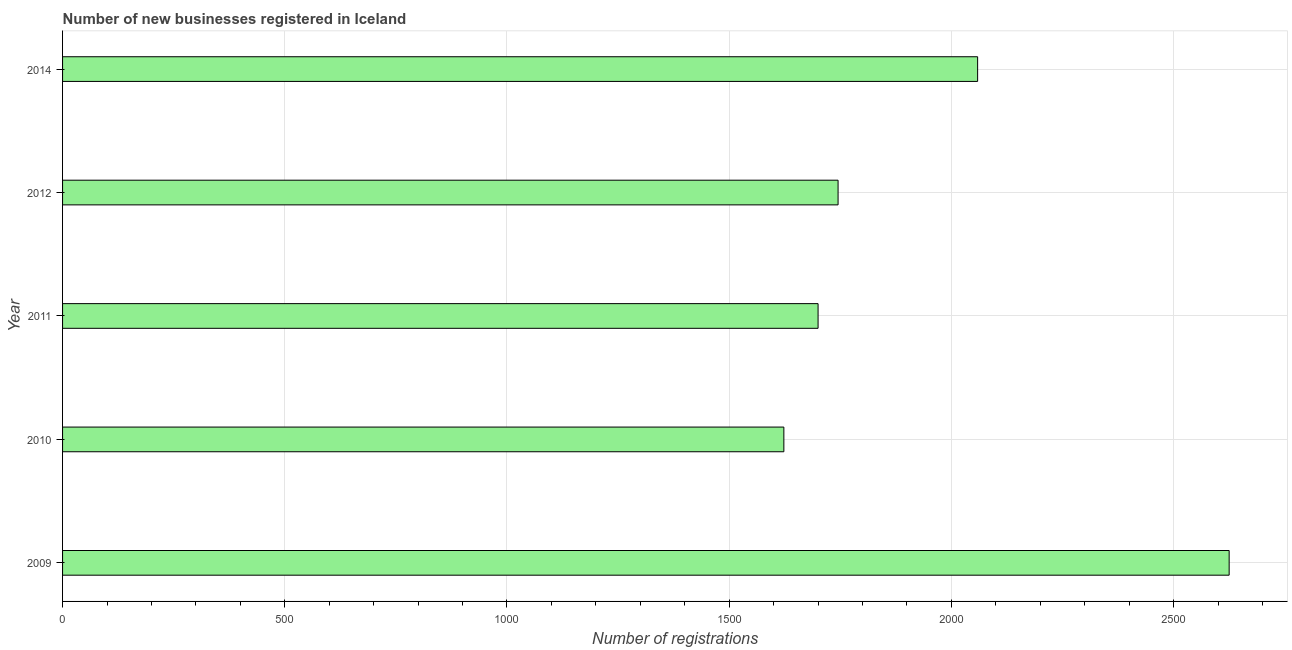Does the graph contain any zero values?
Offer a very short reply. No. What is the title of the graph?
Your answer should be very brief. Number of new businesses registered in Iceland. What is the label or title of the X-axis?
Your answer should be very brief. Number of registrations. What is the number of new business registrations in 2011?
Offer a terse response. 1700. Across all years, what is the maximum number of new business registrations?
Your response must be concise. 2625. Across all years, what is the minimum number of new business registrations?
Your response must be concise. 1623. In which year was the number of new business registrations maximum?
Provide a succinct answer. 2009. What is the sum of the number of new business registrations?
Provide a succinct answer. 9752. What is the difference between the number of new business registrations in 2011 and 2014?
Keep it short and to the point. -359. What is the average number of new business registrations per year?
Keep it short and to the point. 1950. What is the median number of new business registrations?
Provide a short and direct response. 1745. Do a majority of the years between 2010 and 2012 (inclusive) have number of new business registrations greater than 2600 ?
Make the answer very short. No. What is the ratio of the number of new business registrations in 2010 to that in 2014?
Your answer should be compact. 0.79. Is the number of new business registrations in 2009 less than that in 2010?
Ensure brevity in your answer.  No. What is the difference between the highest and the second highest number of new business registrations?
Your answer should be compact. 566. What is the difference between the highest and the lowest number of new business registrations?
Keep it short and to the point. 1002. In how many years, is the number of new business registrations greater than the average number of new business registrations taken over all years?
Your response must be concise. 2. What is the difference between two consecutive major ticks on the X-axis?
Offer a terse response. 500. What is the Number of registrations of 2009?
Offer a terse response. 2625. What is the Number of registrations in 2010?
Ensure brevity in your answer.  1623. What is the Number of registrations in 2011?
Provide a short and direct response. 1700. What is the Number of registrations in 2012?
Give a very brief answer. 1745. What is the Number of registrations in 2014?
Make the answer very short. 2059. What is the difference between the Number of registrations in 2009 and 2010?
Your answer should be very brief. 1002. What is the difference between the Number of registrations in 2009 and 2011?
Provide a short and direct response. 925. What is the difference between the Number of registrations in 2009 and 2012?
Make the answer very short. 880. What is the difference between the Number of registrations in 2009 and 2014?
Make the answer very short. 566. What is the difference between the Number of registrations in 2010 and 2011?
Offer a terse response. -77. What is the difference between the Number of registrations in 2010 and 2012?
Offer a very short reply. -122. What is the difference between the Number of registrations in 2010 and 2014?
Your response must be concise. -436. What is the difference between the Number of registrations in 2011 and 2012?
Your answer should be very brief. -45. What is the difference between the Number of registrations in 2011 and 2014?
Your response must be concise. -359. What is the difference between the Number of registrations in 2012 and 2014?
Provide a short and direct response. -314. What is the ratio of the Number of registrations in 2009 to that in 2010?
Provide a short and direct response. 1.62. What is the ratio of the Number of registrations in 2009 to that in 2011?
Keep it short and to the point. 1.54. What is the ratio of the Number of registrations in 2009 to that in 2012?
Your answer should be compact. 1.5. What is the ratio of the Number of registrations in 2009 to that in 2014?
Offer a terse response. 1.27. What is the ratio of the Number of registrations in 2010 to that in 2011?
Give a very brief answer. 0.95. What is the ratio of the Number of registrations in 2010 to that in 2012?
Your answer should be compact. 0.93. What is the ratio of the Number of registrations in 2010 to that in 2014?
Provide a short and direct response. 0.79. What is the ratio of the Number of registrations in 2011 to that in 2014?
Your answer should be very brief. 0.83. What is the ratio of the Number of registrations in 2012 to that in 2014?
Provide a short and direct response. 0.85. 